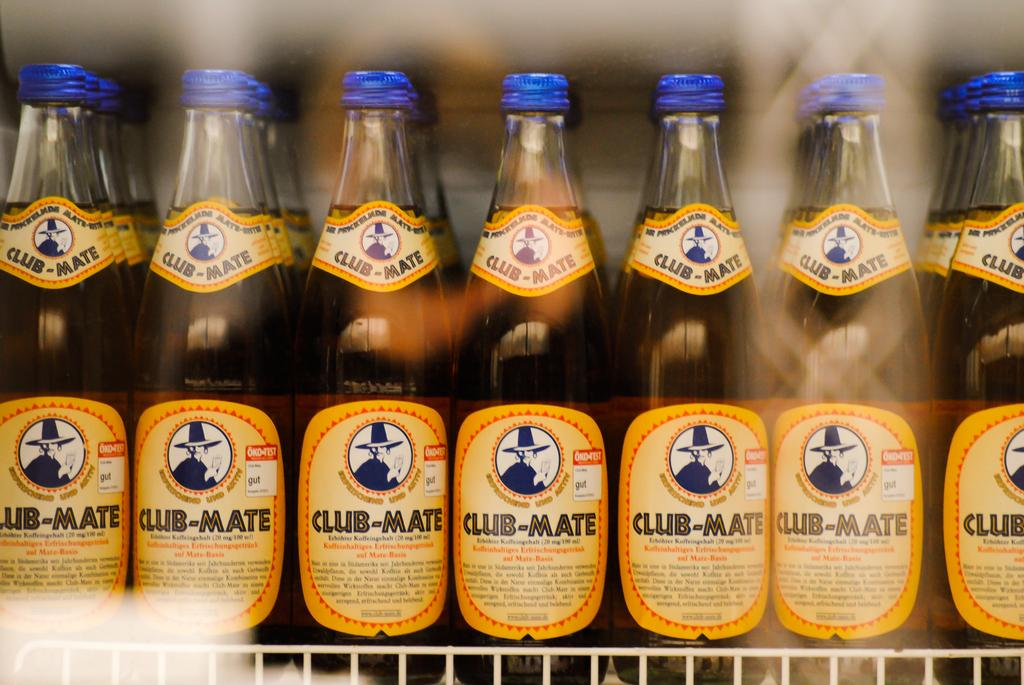<image>
Provide a brief description of the given image. Fridge full of Club-Mate bottles with a blue top 